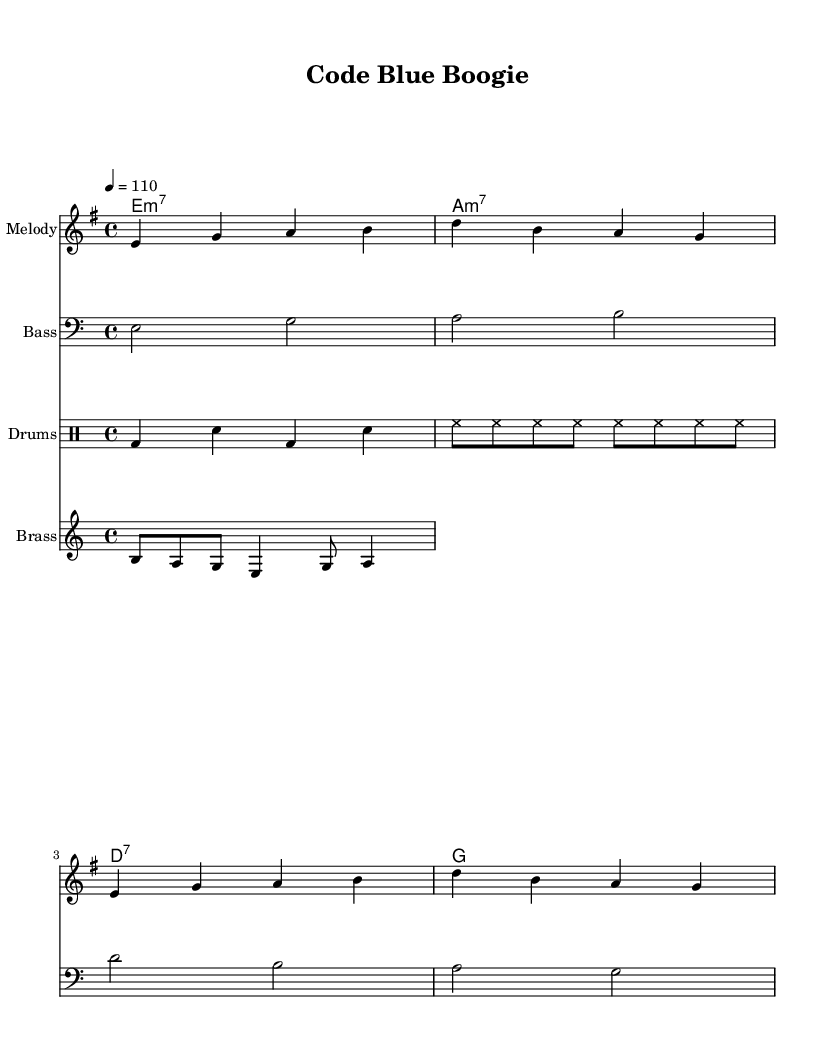What is the key signature of this music? The key signature is E minor, indicated by the presence of one sharp (F#) and the absence of other accidentals.
Answer: E minor What is the time signature of this music? The time signature is 4/4, which means there are four beats in a measure and the quarter note gets one beat. This is identified at the beginning of the sheet music.
Answer: 4/4 What is the tempo of this piece? The tempo is marked as 110 beats per minute, which is indicated in the music as "4 = 110" meaning a quarter note equals 110 beats per minute.
Answer: 110 What is the first note of the melody? The first note of the melody is E, indicated as the first note in the melody line.
Answer: E How many measures are in the melody section? The melody section contains four measures, as each group of notes separated by bar lines counts as one measure, and there are four distinct groups in the melody.
Answer: 4 What is the rhythm pattern for the drums? The drum rhythm pattern includes a kick (bd), snare (sn), and hi-hat (hh), repeating in a specific sequence, giving it a strong funk groove.
Answer: bd, sn, bd, sn, hh What type of chords are being used in the harmony? The harmony consists of minor seventh and dominant seventh chords, which are characteristic of funk music, contributing to its unique sound.
Answer: minor seventh and dominant seventh 